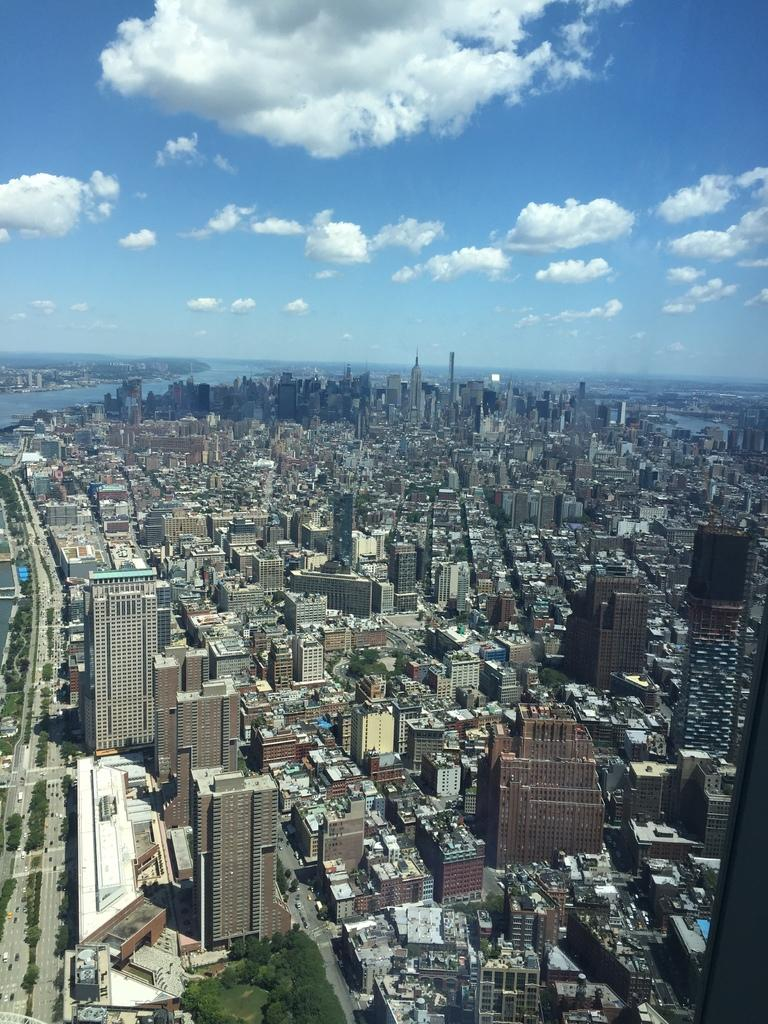What type of structures can be seen in the image? There are buildings in the image. What other natural elements are present in the image? There are trees in the image. What type of transportation infrastructure is visible in the image? There are roads in the image. What are the vehicles in the image used for? The vehicles in the image are used for transportation. What tall structures can be seen in the image? There are towers in the image. What body of water is visible in the image? There is water visible in the image. What part of the natural environment is visible at the top of the image? The sky is visible at the top of the image. What type of beef is being served in the pie in the image? There is no beef or pie present in the image; it features buildings, trees, roads, vehicles, towers, water, and the sky. What advice does the mother in the image give to her child? There is no mother or child present in the image. 